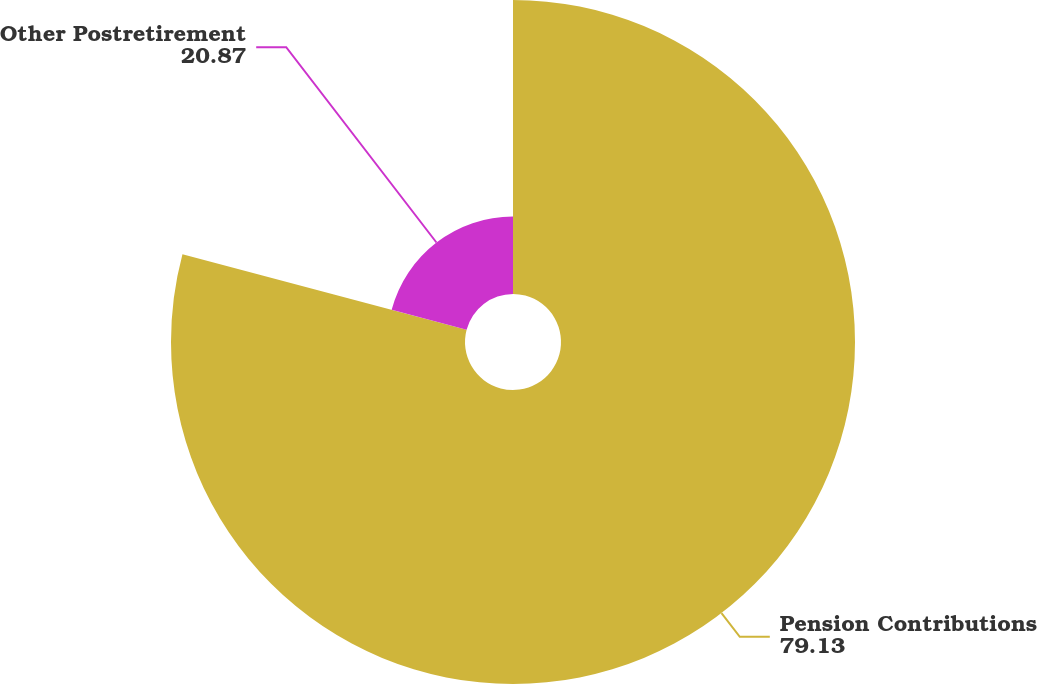Convert chart. <chart><loc_0><loc_0><loc_500><loc_500><pie_chart><fcel>Pension Contributions<fcel>Other Postretirement<nl><fcel>79.13%<fcel>20.87%<nl></chart> 